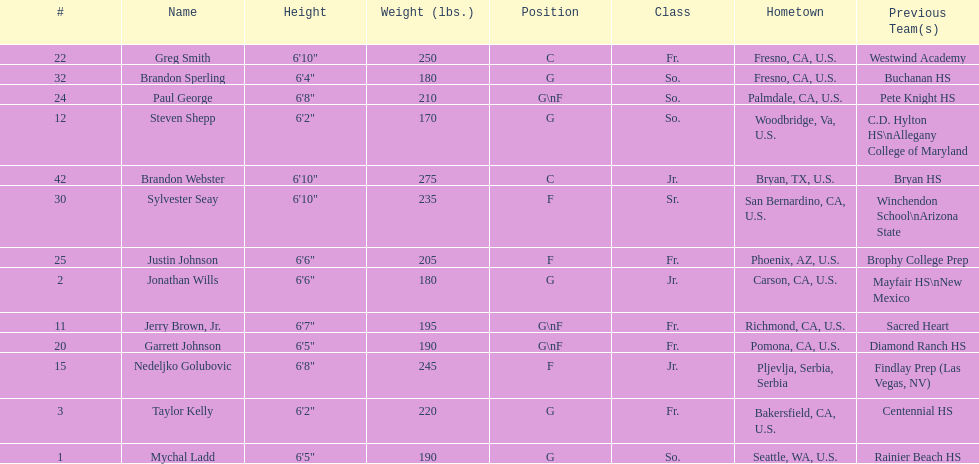Being shorter than 6' 3", taylor kelly shares this trait with which other competitor? Steven Shepp. 